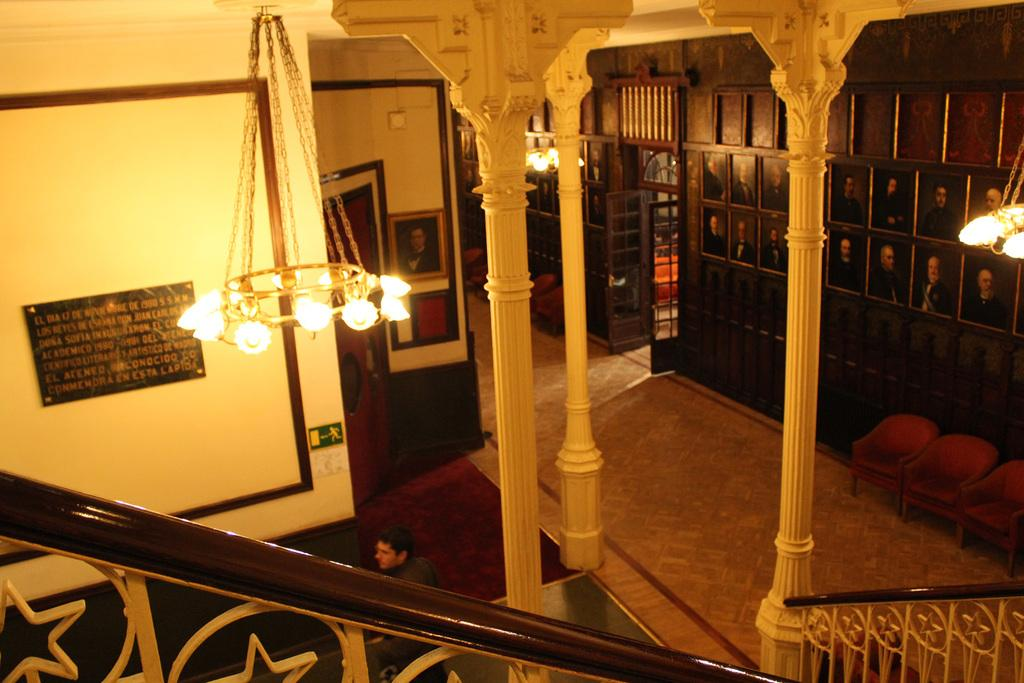What type of lighting fixture is present in the image? There are chandeliers in the image. Can you describe the person in the image? There is a person in the image. What architectural features can be seen in the image? There are pillars in the image. What type of decorative items are present in the image? There are photo frames in the image. What type of background is visible in the image? There is a wall in the image. What type of furniture is present in the image? There are chairs in the image. Are there any other objects visible in the image? Yes, there are other objects in the image. What type of barrier is present at the bottom of the image? There is railing at the bottom of the image. What type of smile does the person have in the image? There is no indication of the person's smile in the image, as the person's facial expression is not described. What hobbies does the person in the image enjoy? There is no information about the person's hobbies in the image. How many legs does the person in the image have? The image does not show the person's legs, so it is impossible to determine the number of legs. 